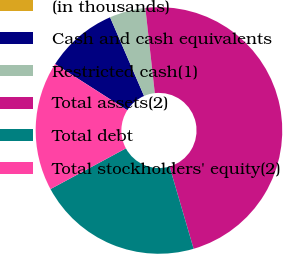<chart> <loc_0><loc_0><loc_500><loc_500><pie_chart><fcel>(in thousands)<fcel>Cash and cash equivalents<fcel>Restricted cash(1)<fcel>Total assets(2)<fcel>Total debt<fcel>Total stockholders' equity(2)<nl><fcel>0.01%<fcel>9.45%<fcel>4.73%<fcel>47.22%<fcel>21.65%<fcel>16.93%<nl></chart> 